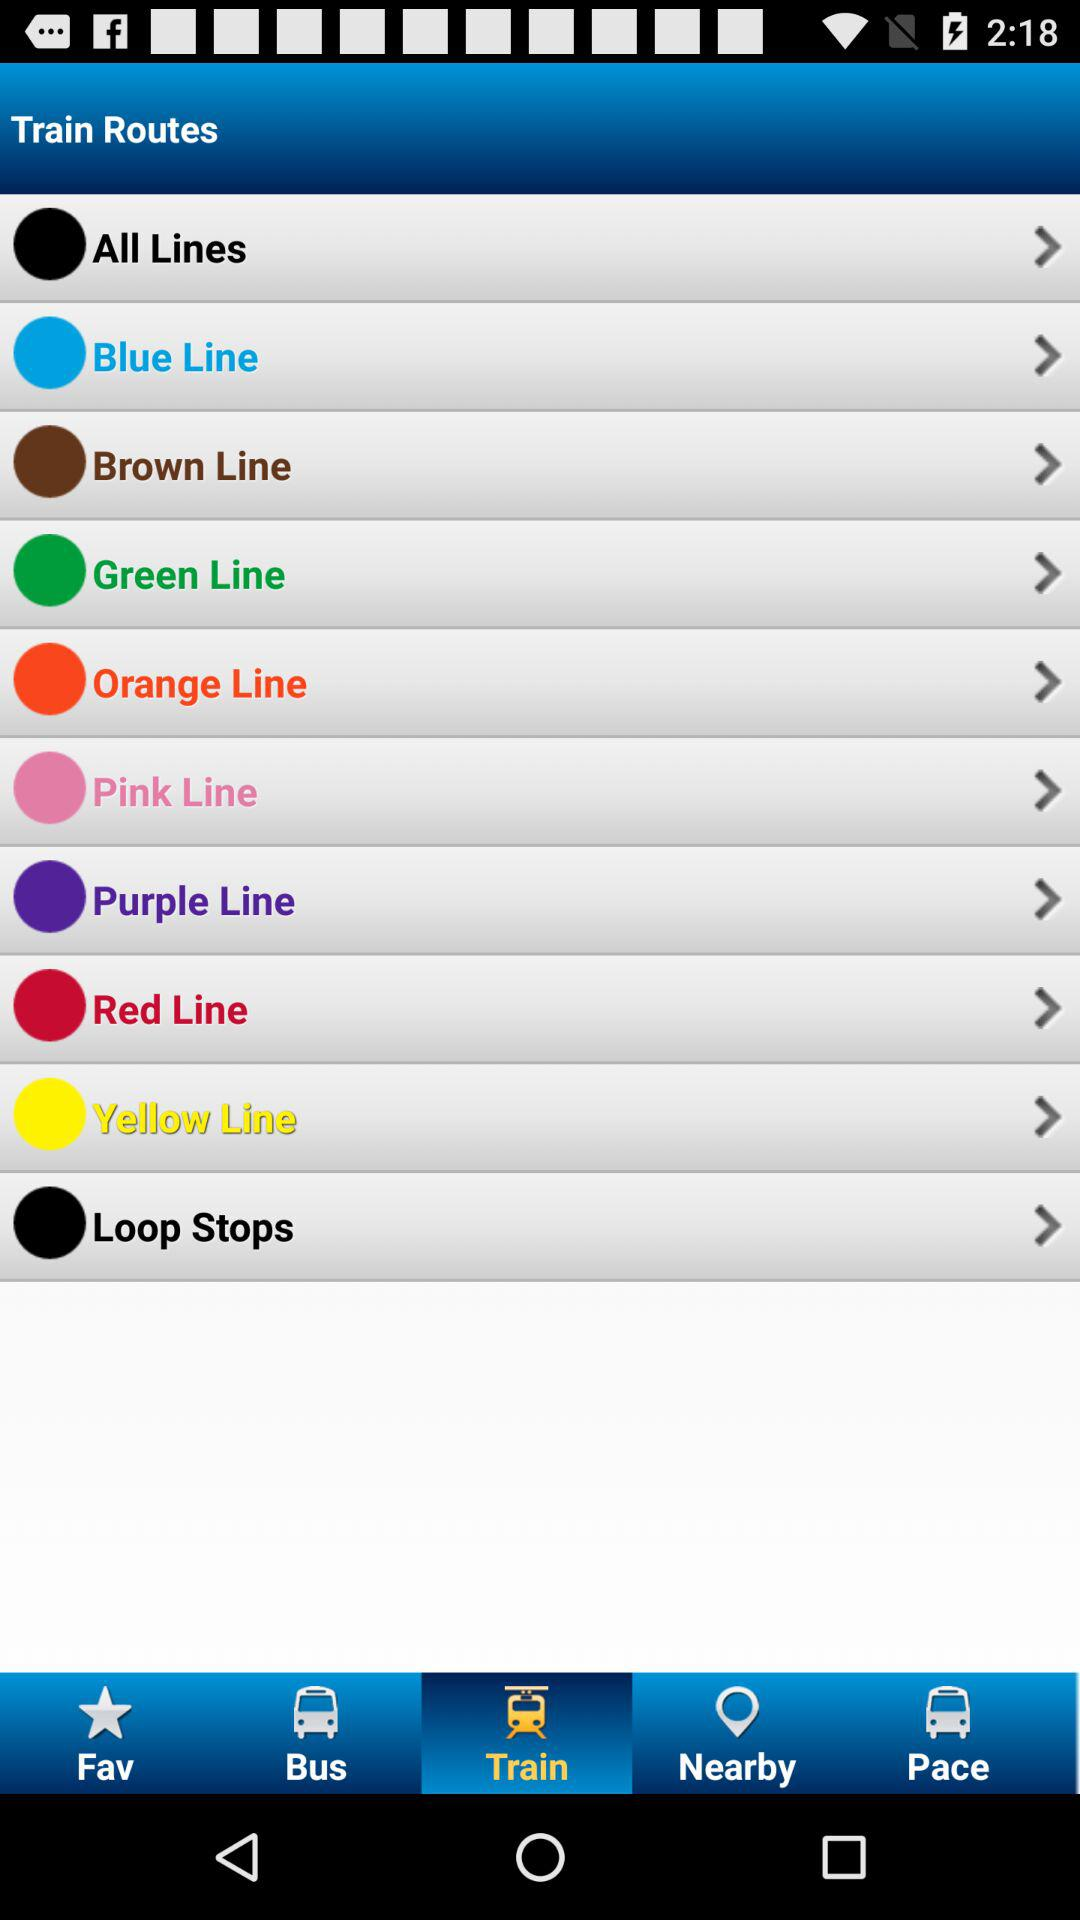Which tab is selected? The selected tab is "Train". 